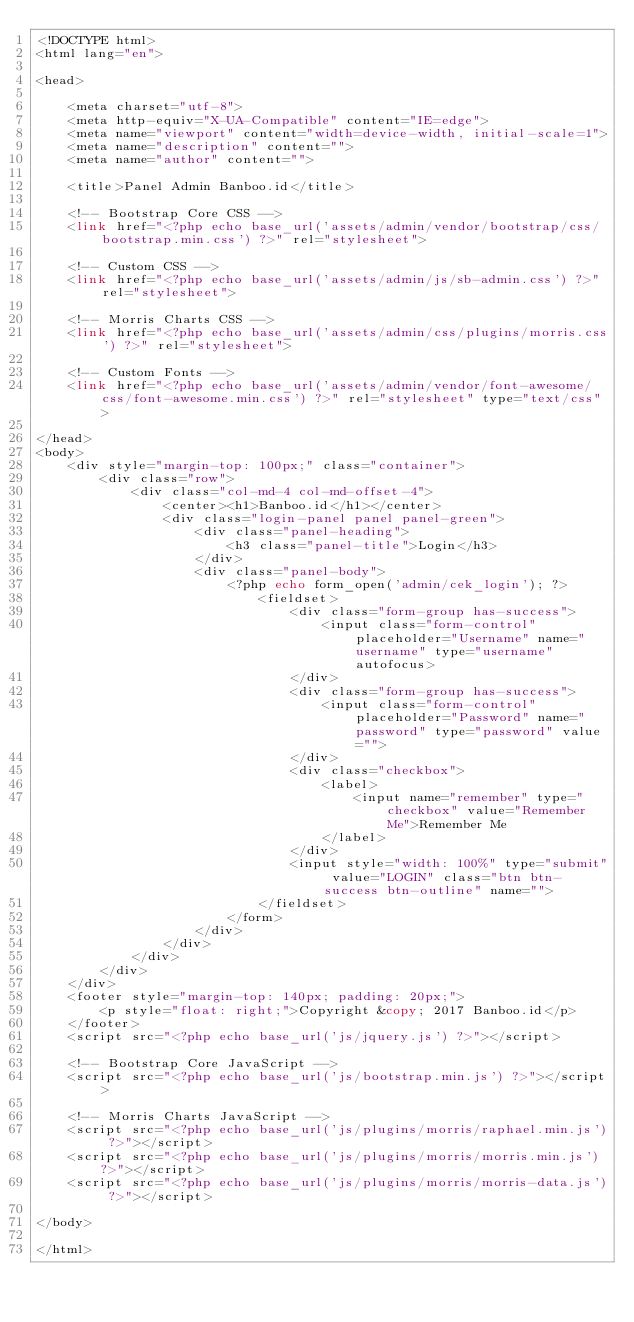Convert code to text. <code><loc_0><loc_0><loc_500><loc_500><_PHP_><!DOCTYPE html>
<html lang="en">

<head>

    <meta charset="utf-8">
    <meta http-equiv="X-UA-Compatible" content="IE=edge">
    <meta name="viewport" content="width=device-width, initial-scale=1">
    <meta name="description" content="">
    <meta name="author" content="">

    <title>Panel Admin Banboo.id</title>

    <!-- Bootstrap Core CSS -->
    <link href="<?php echo base_url('assets/admin/vendor/bootstrap/css/bootstrap.min.css') ?>" rel="stylesheet">

    <!-- Custom CSS -->
    <link href="<?php echo base_url('assets/admin/js/sb-admin.css') ?>" rel="stylesheet">

    <!-- Morris Charts CSS -->
    <link href="<?php echo base_url('assets/admin/css/plugins/morris.css') ?>" rel="stylesheet">

    <!-- Custom Fonts -->
    <link href="<?php echo base_url('assets/admin/vendor/font-awesome/css/font-awesome.min.css') ?>" rel="stylesheet" type="text/css">

</head>
<body>
    <div style="margin-top: 100px;" class="container">
        <div class="row">
            <div class="col-md-4 col-md-offset-4">
                <center><h1>Banboo.id</h1></center>
                <div class="login-panel panel panel-green">
                    <div class="panel-heading">
                        <h3 class="panel-title">Login</h3>
                    </div>
                    <div class="panel-body">
                        <?php echo form_open('admin/cek_login'); ?>
                            <fieldset>
                                <div class="form-group has-success">
                                    <input class="form-control" placeholder="Username" name="username" type="username" autofocus>
                                </div>
                                <div class="form-group has-success">
                                    <input class="form-control" placeholder="Password" name="password" type="password" value="">
                                </div>
                                <div class="checkbox">
                                    <label>
                                        <input name="remember" type="checkbox" value="Remember Me">Remember Me
                                    </label>
                                </div>
                                <input style="width: 100%" type="submit" value="LOGIN" class="btn btn-success btn-outline" name="">
                            </fieldset>
                        </form>
                    </div>
                </div>
            </div>
        </div>
    </div>
    <footer style="margin-top: 140px; padding: 20px;">
        <p style="float: right;">Copyright &copy; 2017 Banboo.id</p>
    </footer>
    <script src="<?php echo base_url('js/jquery.js') ?>"></script>

    <!-- Bootstrap Core JavaScript -->
    <script src="<?php echo base_url('js/bootstrap.min.js') ?>"></script>

    <!-- Morris Charts JavaScript -->
    <script src="<?php echo base_url('js/plugins/morris/raphael.min.js') ?>"></script>
    <script src="<?php echo base_url('js/plugins/morris/morris.min.js') ?>"></script>
    <script src="<?php echo base_url('js/plugins/morris/morris-data.js') ?>"></script>

</body>

</html></code> 